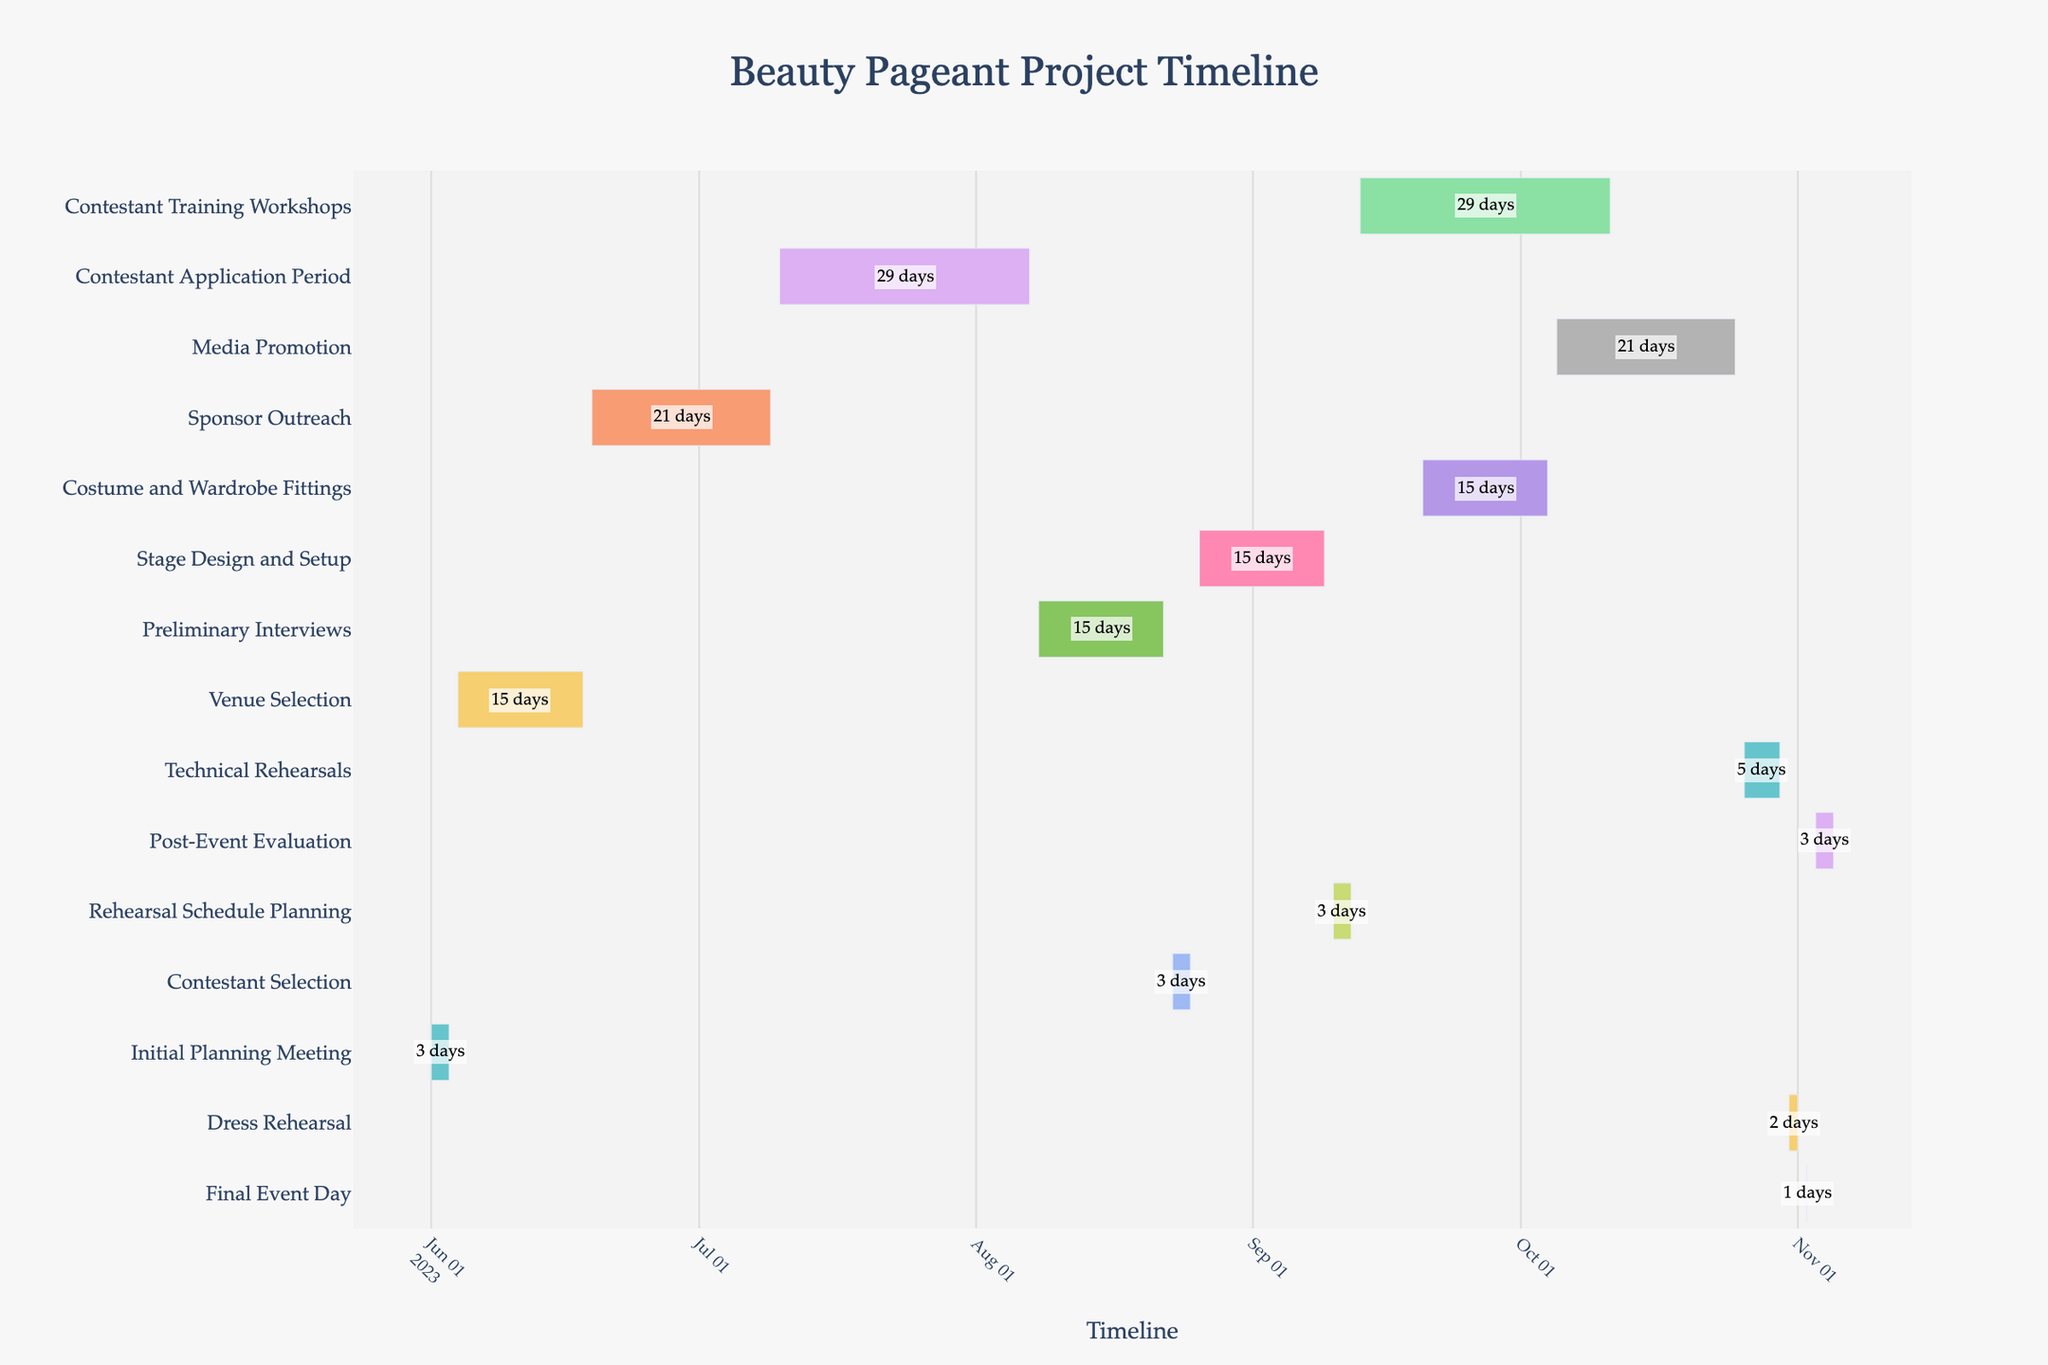What is the total duration of the Costume and Wardrobe Fittings stage? First, identify the Costume and Wardrobe Fittings stage on the y-axis. Then, check its start date (2023-09-20) and end date (2023-10-04). The duration is given as 15 days.
Answer: 15 days During which time period will the Contestant Application Period take place? Locate the Contestant Application Period on the y-axis. The hover information or the bar itself shows it starts on 2023-07-10 and ends on 2023-08-07.
Answer: 2023-07-10 to 2023-08-07 Which stage has the longest duration? Scan the Gantt chart for the task with the longest bar. The Contestant Training Workshops stage, from 2023-09-13 to 2023-10-11, has the longest duration of 29 days.
Answer: Contestant Training Workshops How many days are allocated for the Technical Rehearsals stage? Locate the Technical Rehearsals stage on the y-axis. The hover information shows it starts on 2023-10-26 and ends on 2023-10-30, for a duration of 5 days.
Answer: 5 days Which tasks overlap with the Media Promotion stage? The Media Promotion stage runs from 2023-10-05 to 2023-10-25. Check the tasks that share this period, including Contestant Training Workshops and Costume and Wardrobe Fittings.
Answer: Contestant Training Workshops, Costume and Wardrobe Fittings What is the total duration of the Preliminary Interviews and Contestant Selection stages combined? Identify the durations of Preliminary Interviews (15 days) and Contestant Selection (3 days). Sum 15 + 3 = 18 days.
Answer: 18 days Which event follows the Final Event Day directly? Locate the Final Event Day stage, dated 2023-11-02. The subsequent stage is the Post-Event Evaluation starting on 2023-11-03.
Answer: Post-Event Evaluation What is the average duration of the Venue Selection and Sponsor Outreach stages? Venue Selection lasts from 2023-06-04 to 2023-06-18 (15 days), and Sponsor Outreach from 2023-06-19 to 2023-07-09 (21 days). Calculate the average: (15 + 21) / 2 = 18 days.
Answer: 18 days Compare the durations of Stage Design and Setup with Rehearsal Schedule Planning. Which is longer and by how many days? Stage Design and Setup lasts 15 days, while Rehearsal Schedule Planning spans 3 days. The difference is 15 - 3 = 12 days.
Answer: Stage Design and Setup by 12 days When does the Rehearsal Schedule Planning stage begin and end? Locate Rehearsal Schedule Planning on the y-axis. It starts on 2023-09-10 and ends on 2023-09-12.
Answer: 2023-09-10 to 2023-09-12 